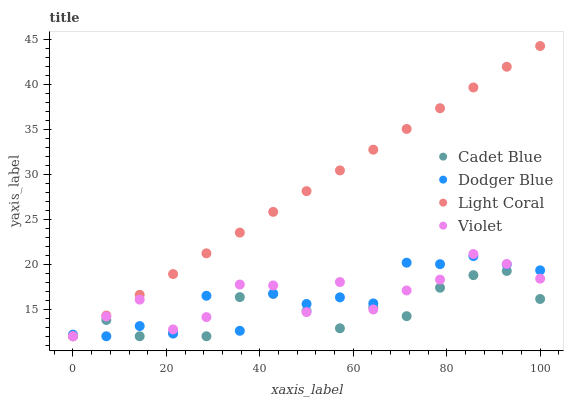Does Cadet Blue have the minimum area under the curve?
Answer yes or no. Yes. Does Light Coral have the maximum area under the curve?
Answer yes or no. Yes. Does Dodger Blue have the minimum area under the curve?
Answer yes or no. No. Does Dodger Blue have the maximum area under the curve?
Answer yes or no. No. Is Light Coral the smoothest?
Answer yes or no. Yes. Is Dodger Blue the roughest?
Answer yes or no. Yes. Is Cadet Blue the smoothest?
Answer yes or no. No. Is Cadet Blue the roughest?
Answer yes or no. No. Does Light Coral have the lowest value?
Answer yes or no. Yes. Does Light Coral have the highest value?
Answer yes or no. Yes. Does Dodger Blue have the highest value?
Answer yes or no. No. Does Dodger Blue intersect Cadet Blue?
Answer yes or no. Yes. Is Dodger Blue less than Cadet Blue?
Answer yes or no. No. Is Dodger Blue greater than Cadet Blue?
Answer yes or no. No. 